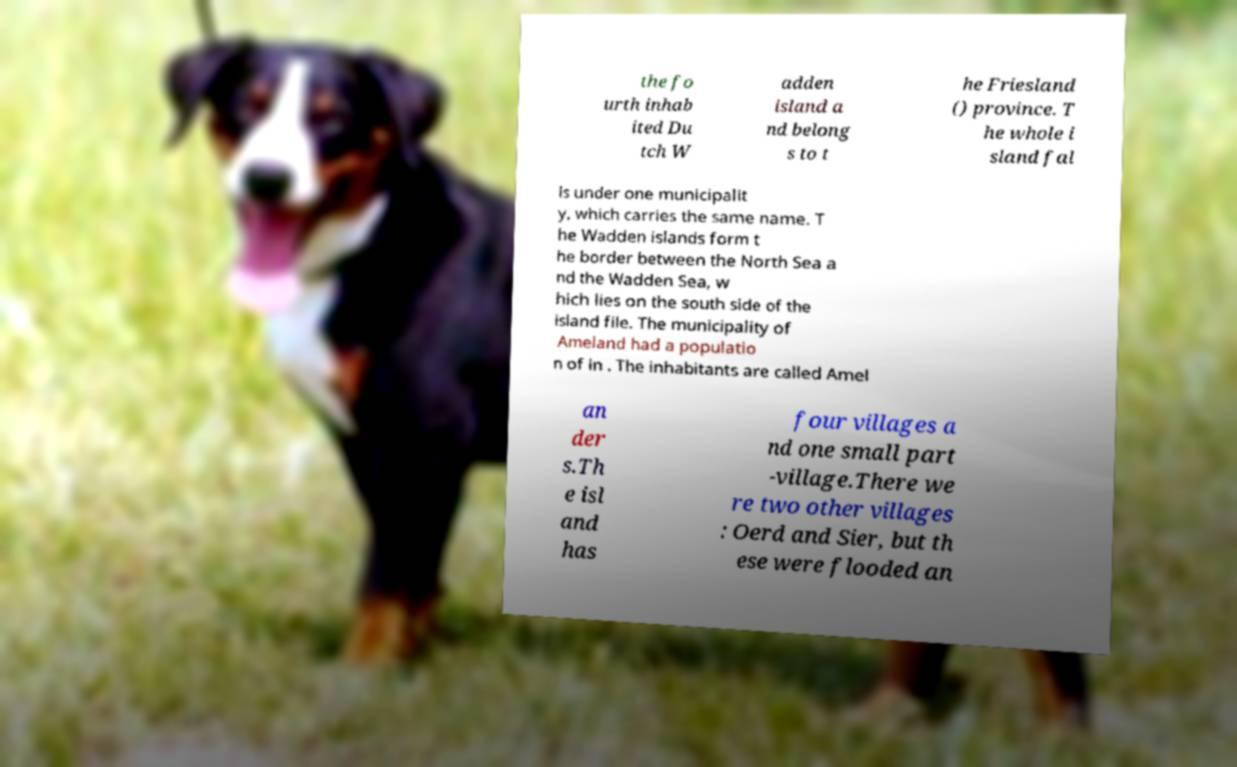Could you extract and type out the text from this image? the fo urth inhab ited Du tch W adden island a nd belong s to t he Friesland () province. T he whole i sland fal ls under one municipalit y, which carries the same name. T he Wadden islands form t he border between the North Sea a nd the Wadden Sea, w hich lies on the south side of the island file. The municipality of Ameland had a populatio n of in . The inhabitants are called Amel an der s.Th e isl and has four villages a nd one small part -village.There we re two other villages : Oerd and Sier, but th ese were flooded an 